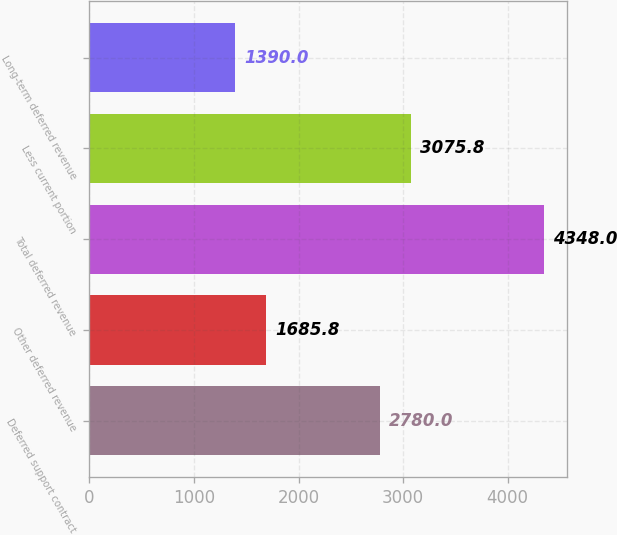Convert chart to OTSL. <chart><loc_0><loc_0><loc_500><loc_500><bar_chart><fcel>Deferred support contract<fcel>Other deferred revenue<fcel>Total deferred revenue<fcel>Less current portion<fcel>Long-term deferred revenue<nl><fcel>2780<fcel>1685.8<fcel>4348<fcel>3075.8<fcel>1390<nl></chart> 